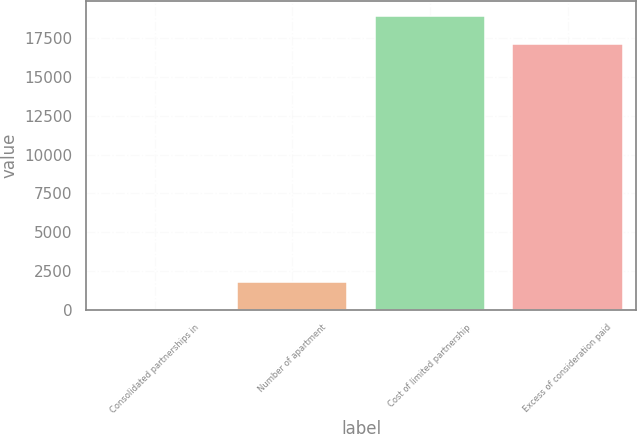Convert chart to OTSL. <chart><loc_0><loc_0><loc_500><loc_500><bar_chart><fcel>Consolidated partnerships in<fcel>Number of apartment<fcel>Cost of limited partnership<fcel>Excess of consideration paid<nl><fcel>3<fcel>1792.7<fcel>18959.7<fcel>17170<nl></chart> 